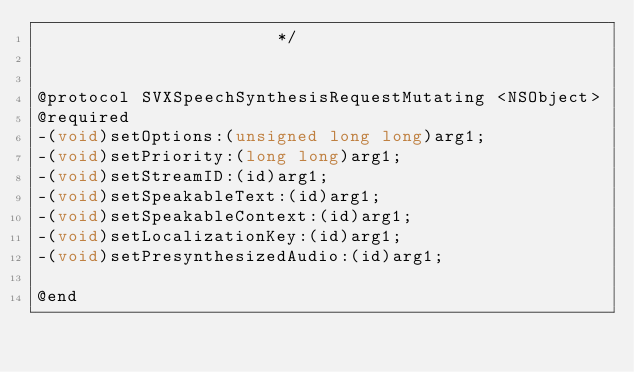Convert code to text. <code><loc_0><loc_0><loc_500><loc_500><_C_>                       */


@protocol SVXSpeechSynthesisRequestMutating <NSObject>
@required
-(void)setOptions:(unsigned long long)arg1;
-(void)setPriority:(long long)arg1;
-(void)setStreamID:(id)arg1;
-(void)setSpeakableText:(id)arg1;
-(void)setSpeakableContext:(id)arg1;
-(void)setLocalizationKey:(id)arg1;
-(void)setPresynthesizedAudio:(id)arg1;

@end

</code> 